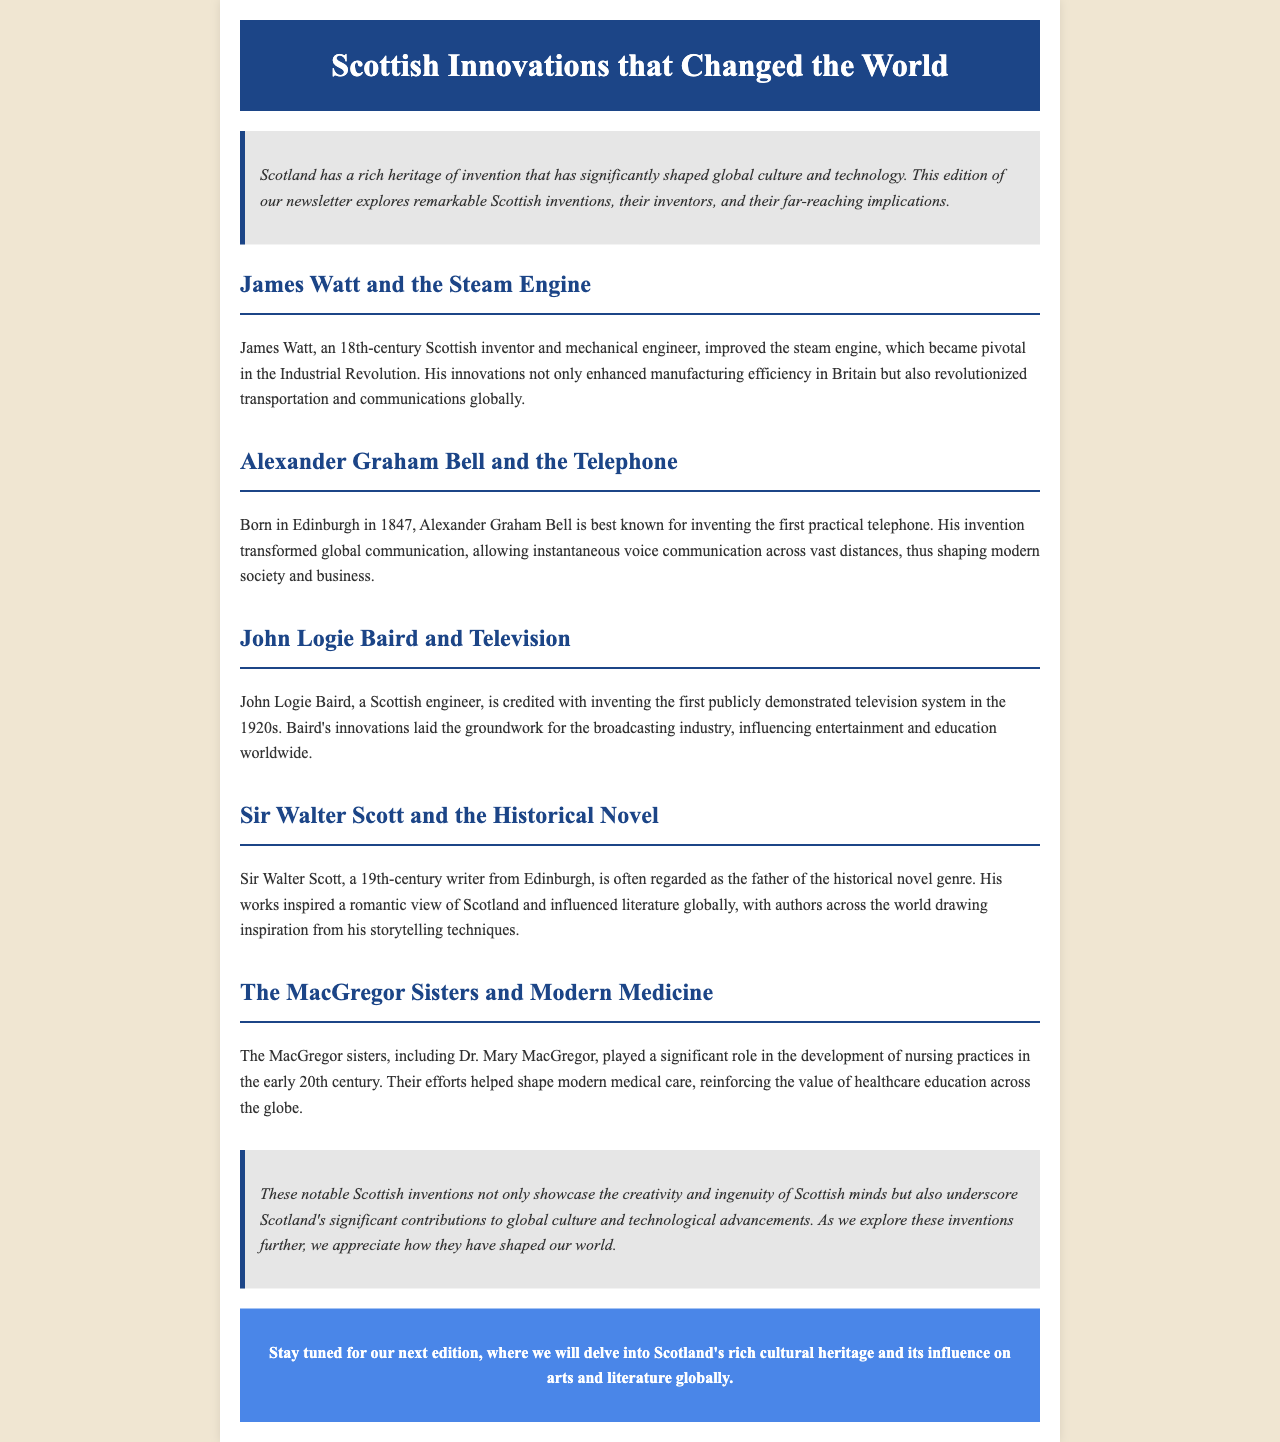What invention did James Watt improve? James Watt is known for improving the steam engine, which is mentioned in the document.
Answer: steam engine Who invented the first practical telephone? The document states that Alexander Graham Bell is best known for inventing the first practical telephone.
Answer: Alexander Graham Bell In what year was Alexander Graham Bell born? The document indicates that Alexander Graham Bell was born in 1847.
Answer: 1847 What genre did Sir Walter Scott contribute to? Sir Walter Scott is recognized as the father of the historical novel genre according to the document.
Answer: historical novel Which Scottish inventor is credited with the first publicly demonstrated television system? The document names John Logie Baird as the inventor credited with this innovation.
Answer: John Logie Baird What impact did the MacGregor sisters have on medicine? The document mentions that the MacGregor sisters helped shape modern medical care.
Answer: modern medical care What is the primary focus of this newsletter edition? The document states that this edition explores notable Scottish inventions and their global implications.
Answer: Scottish inventions What type of document is this? The structure and content indicate that this is a newsletter about Scottish innovations.
Answer: newsletter 